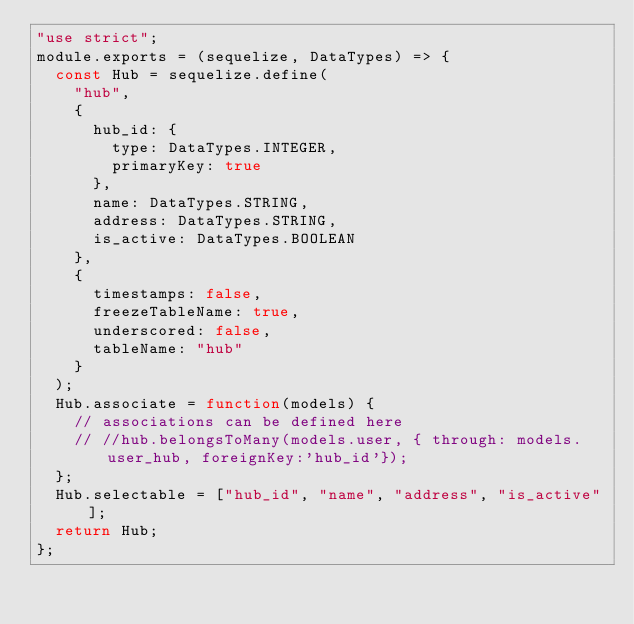<code> <loc_0><loc_0><loc_500><loc_500><_JavaScript_>"use strict";
module.exports = (sequelize, DataTypes) => {
  const Hub = sequelize.define(
    "hub",
    {
      hub_id: {
        type: DataTypes.INTEGER,
        primaryKey: true
      },
      name: DataTypes.STRING,
      address: DataTypes.STRING,
      is_active: DataTypes.BOOLEAN
    },
    {
      timestamps: false,
      freezeTableName: true,
      underscored: false,
      tableName: "hub"
    }
  );
  Hub.associate = function(models) {
    // associations can be defined here
    // //hub.belongsToMany(models.user, { through: models.user_hub, foreignKey:'hub_id'});
  };
  Hub.selectable = ["hub_id", "name", "address", "is_active"];
  return Hub;
};
</code> 